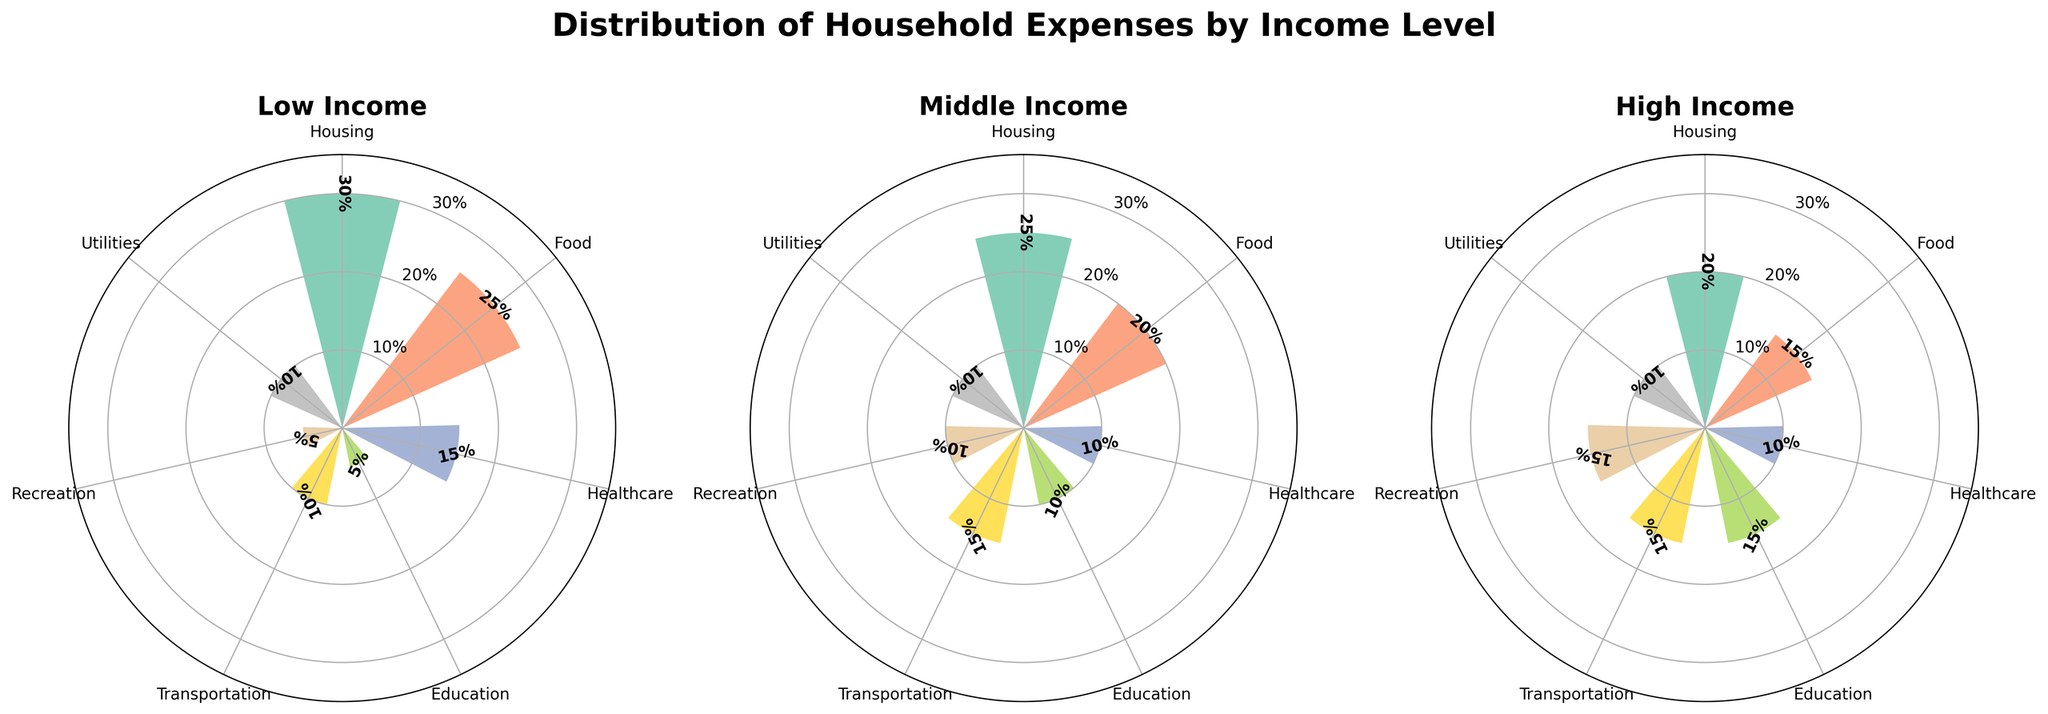Which income level spends the highest percentage on housing? By observing the rose chart for the Low, Middle, and High-income levels, we see that the Low-income group has the longest bar for housing at 30%.
Answer: Low-income What is the combined percentage of healthcare and education expenses for the Middle-income group? The Middle-income group spends 10% on healthcare and 10% on education. Adding these two values results in 10% + 10% = 20%.
Answer: 20% Do higher income levels spend more on recreation than lower income levels? In the rose chart, the High-income group spends 15% on recreation, the Middle-income group spends 10%, and the Low-income group spends 5%. Thus, higher income levels spend more on recreation.
Answer: Yes What are the top three expense categories for the High-income group? By examining the High-income group on the rose chart, the categories with the highest percentages are Education (15%), Transportation (15%), and Recreation (15%).
Answer: Education, Transportation, Recreation Which category appears to be consistent across all income levels in terms of percentage allocation? By comparing all the bars, the Utilities category consistently appears to be set at 10% across the Low, Middle, and High-income groups.
Answer: Utilities How much more does the Low-income group spend on food compared to the High-income group? The Low-income group spends 25% on food, while the High-income group spends 15%. The difference is 25% - 15% = 10%.
Answer: 10% What is the percentage difference in spending on education between Low and High-income groups? The Low-income group allocates 5% to education, and the High-income group allocates 15%. The difference is 15% - 5% = 10%.
Answer: 10% Which income group allocates the smallest percentage to recreation, and what is that percentage? Observing all income levels, the Low-income group allocates 5% to recreation, which is the smallest percentage among the groups.
Answer: Low-income, 5% Which income group has the most varied distribution of expenses? By visual inspection, the Low-income group shows the highest variability in expense distributions, with percentages ranging from 5% to 30%, whereas other groups have more balanced distributions.
Answer: Low-income 